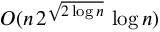Convert formula to latex. <formula><loc_0><loc_0><loc_500><loc_500>O ( n \, 2 ^ { \sqrt { 2 \log n } } \, \log n )</formula> 